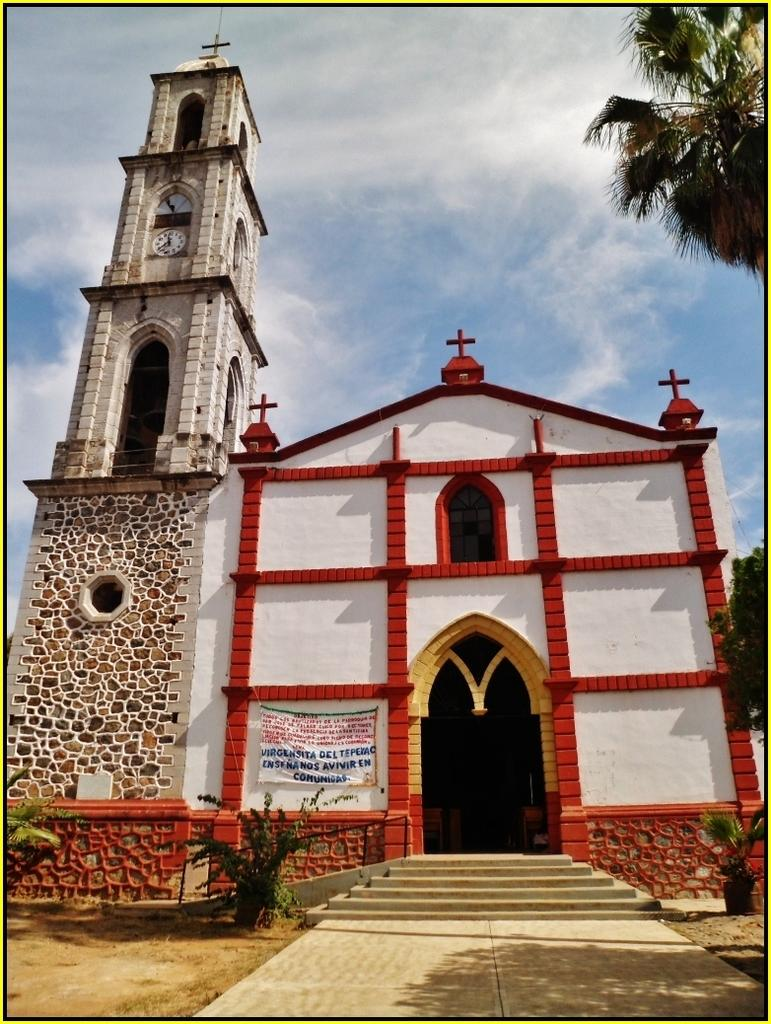What type of building is in the image? There is a church in the image. What distinguishing feature can be seen on the church? The church has cross symbols on it. What time-telling device is present in the image? There is a clock in the image. What type of vegetation is visible in the image? There are plants and trees in the image. What architectural feature is present in the image? There is a staircase in the image. What part of the natural environment is visible in the image? The sky is visible in the image. What type of army vehicles can be seen in the image? There are no army vehicles present in the image. How fast are the cars running in the image? There are no cars present in the image, so their speed cannot be determined. 